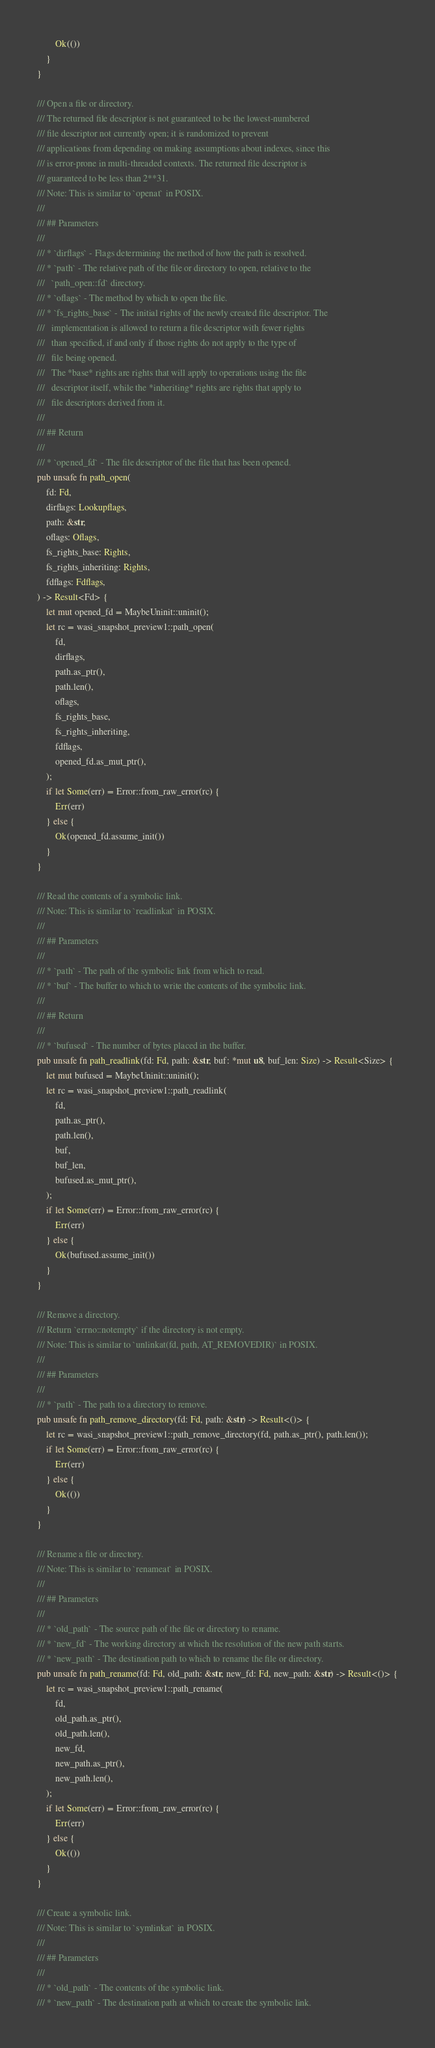Convert code to text. <code><loc_0><loc_0><loc_500><loc_500><_Rust_>        Ok(())
    }
}

/// Open a file or directory.
/// The returned file descriptor is not guaranteed to be the lowest-numbered
/// file descriptor not currently open; it is randomized to prevent
/// applications from depending on making assumptions about indexes, since this
/// is error-prone in multi-threaded contexts. The returned file descriptor is
/// guaranteed to be less than 2**31.
/// Note: This is similar to `openat` in POSIX.
///
/// ## Parameters
///
/// * `dirflags` - Flags determining the method of how the path is resolved.
/// * `path` - The relative path of the file or directory to open, relative to the
///   `path_open::fd` directory.
/// * `oflags` - The method by which to open the file.
/// * `fs_rights_base` - The initial rights of the newly created file descriptor. The
///   implementation is allowed to return a file descriptor with fewer rights
///   than specified, if and only if those rights do not apply to the type of
///   file being opened.
///   The *base* rights are rights that will apply to operations using the file
///   descriptor itself, while the *inheriting* rights are rights that apply to
///   file descriptors derived from it.
///
/// ## Return
///
/// * `opened_fd` - The file descriptor of the file that has been opened.
pub unsafe fn path_open(
    fd: Fd,
    dirflags: Lookupflags,
    path: &str,
    oflags: Oflags,
    fs_rights_base: Rights,
    fs_rights_inheriting: Rights,
    fdflags: Fdflags,
) -> Result<Fd> {
    let mut opened_fd = MaybeUninit::uninit();
    let rc = wasi_snapshot_preview1::path_open(
        fd,
        dirflags,
        path.as_ptr(),
        path.len(),
        oflags,
        fs_rights_base,
        fs_rights_inheriting,
        fdflags,
        opened_fd.as_mut_ptr(),
    );
    if let Some(err) = Error::from_raw_error(rc) {
        Err(err)
    } else {
        Ok(opened_fd.assume_init())
    }
}

/// Read the contents of a symbolic link.
/// Note: This is similar to `readlinkat` in POSIX.
///
/// ## Parameters
///
/// * `path` - The path of the symbolic link from which to read.
/// * `buf` - The buffer to which to write the contents of the symbolic link.
///
/// ## Return
///
/// * `bufused` - The number of bytes placed in the buffer.
pub unsafe fn path_readlink(fd: Fd, path: &str, buf: *mut u8, buf_len: Size) -> Result<Size> {
    let mut bufused = MaybeUninit::uninit();
    let rc = wasi_snapshot_preview1::path_readlink(
        fd,
        path.as_ptr(),
        path.len(),
        buf,
        buf_len,
        bufused.as_mut_ptr(),
    );
    if let Some(err) = Error::from_raw_error(rc) {
        Err(err)
    } else {
        Ok(bufused.assume_init())
    }
}

/// Remove a directory.
/// Return `errno::notempty` if the directory is not empty.
/// Note: This is similar to `unlinkat(fd, path, AT_REMOVEDIR)` in POSIX.
///
/// ## Parameters
///
/// * `path` - The path to a directory to remove.
pub unsafe fn path_remove_directory(fd: Fd, path: &str) -> Result<()> {
    let rc = wasi_snapshot_preview1::path_remove_directory(fd, path.as_ptr(), path.len());
    if let Some(err) = Error::from_raw_error(rc) {
        Err(err)
    } else {
        Ok(())
    }
}

/// Rename a file or directory.
/// Note: This is similar to `renameat` in POSIX.
///
/// ## Parameters
///
/// * `old_path` - The source path of the file or directory to rename.
/// * `new_fd` - The working directory at which the resolution of the new path starts.
/// * `new_path` - The destination path to which to rename the file or directory.
pub unsafe fn path_rename(fd: Fd, old_path: &str, new_fd: Fd, new_path: &str) -> Result<()> {
    let rc = wasi_snapshot_preview1::path_rename(
        fd,
        old_path.as_ptr(),
        old_path.len(),
        new_fd,
        new_path.as_ptr(),
        new_path.len(),
    );
    if let Some(err) = Error::from_raw_error(rc) {
        Err(err)
    } else {
        Ok(())
    }
}

/// Create a symbolic link.
/// Note: This is similar to `symlinkat` in POSIX.
///
/// ## Parameters
///
/// * `old_path` - The contents of the symbolic link.
/// * `new_path` - The destination path at which to create the symbolic link.</code> 